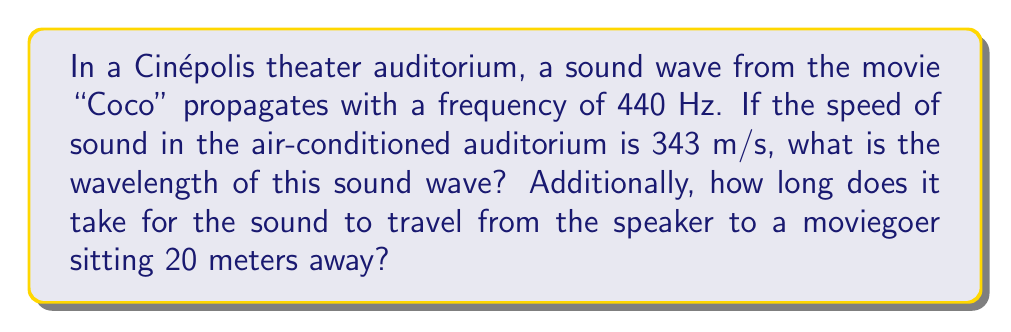Show me your answer to this math problem. Let's approach this problem step by step:

1. Calculate the wavelength:
   The wavelength ($\lambda$) is related to the frequency ($f$) and speed of sound ($v$) by the equation:
   
   $$v = f\lambda$$
   
   Rearranging this equation, we get:
   
   $$\lambda = \frac{v}{f}$$
   
   Substituting the given values:
   
   $$\lambda = \frac{343 \text{ m/s}}{440 \text{ Hz}} = 0.78\text{ m}$$

2. Calculate the time for sound to reach the moviegoer:
   We can use the basic equation relating distance ($d$), speed ($v$), and time ($t$):
   
   $$d = vt$$
   
   Rearranging to solve for time:
   
   $$t = \frac{d}{v}$$
   
   Substituting the given values:
   
   $$t = \frac{20\text{ m}}{343\text{ m/s}} = 0.0583\text{ s}$$

Therefore, the wavelength of the sound is 0.78 m, and it takes 0.0583 seconds (or about 58.3 milliseconds) for the sound to reach the moviegoer.
Answer: Wavelength: 0.78 m; Time to reach moviegoer: 0.0583 s 